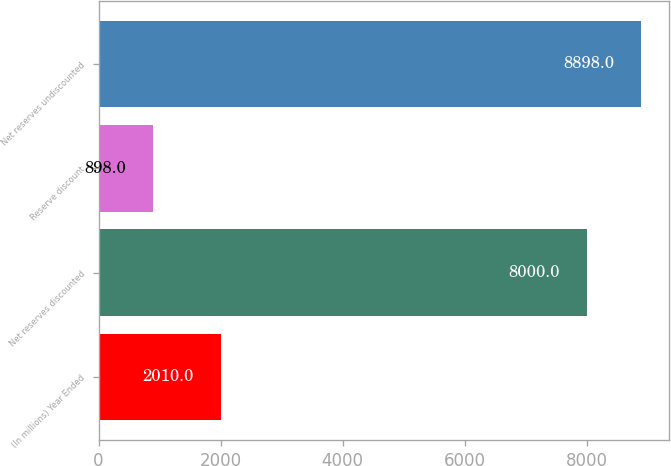Convert chart. <chart><loc_0><loc_0><loc_500><loc_500><bar_chart><fcel>(In millions) Year Ended<fcel>Net reserves discounted<fcel>Reserve discount<fcel>Net reserves undiscounted<nl><fcel>2010<fcel>8000<fcel>898<fcel>8898<nl></chart> 